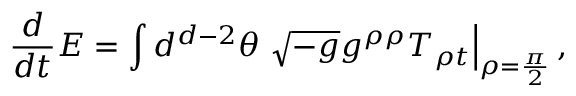Convert formula to latex. <formula><loc_0><loc_0><loc_500><loc_500>{ \frac { d } { d t } } E = \int d ^ { d - 2 } \theta \sqrt { - g } g ^ { \rho \rho } T _ { \rho t } \right | _ { \rho = { \frac { \pi } { 2 } } } ,</formula> 